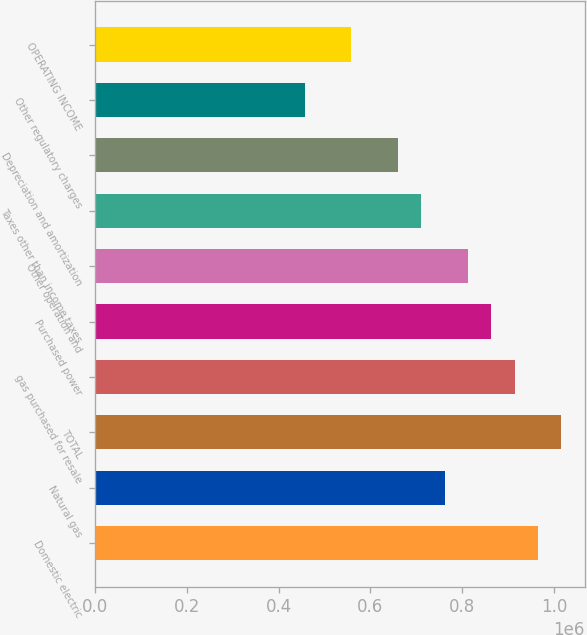Convert chart to OTSL. <chart><loc_0><loc_0><loc_500><loc_500><bar_chart><fcel>Domestic electric<fcel>Natural gas<fcel>TOTAL<fcel>gas purchased for resale<fcel>Purchased power<fcel>Other operation and<fcel>Taxes other than income taxes<fcel>Depreciation and amortization<fcel>Other regulatory charges<fcel>OPERATING INCOME<nl><fcel>964754<fcel>761696<fcel>1.01552e+06<fcel>913989<fcel>863225<fcel>812460<fcel>710932<fcel>660167<fcel>457110<fcel>558638<nl></chart> 